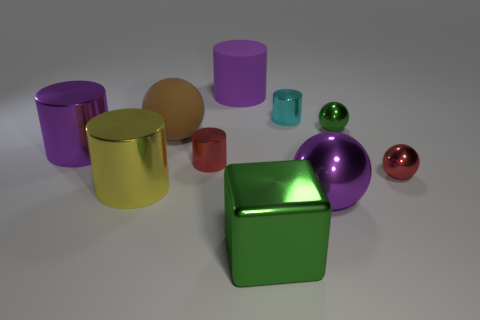Subtract all big purple metal cylinders. How many cylinders are left? 4 Subtract all balls. How many objects are left? 6 Subtract 4 cylinders. How many cylinders are left? 1 Subtract all small metallic cylinders. Subtract all red things. How many objects are left? 6 Add 5 big purple shiny objects. How many big purple shiny objects are left? 7 Add 8 small purple cylinders. How many small purple cylinders exist? 8 Subtract all yellow cylinders. How many cylinders are left? 4 Subtract 1 yellow cylinders. How many objects are left? 9 Subtract all red cylinders. Subtract all purple spheres. How many cylinders are left? 4 Subtract all red cylinders. How many gray cubes are left? 0 